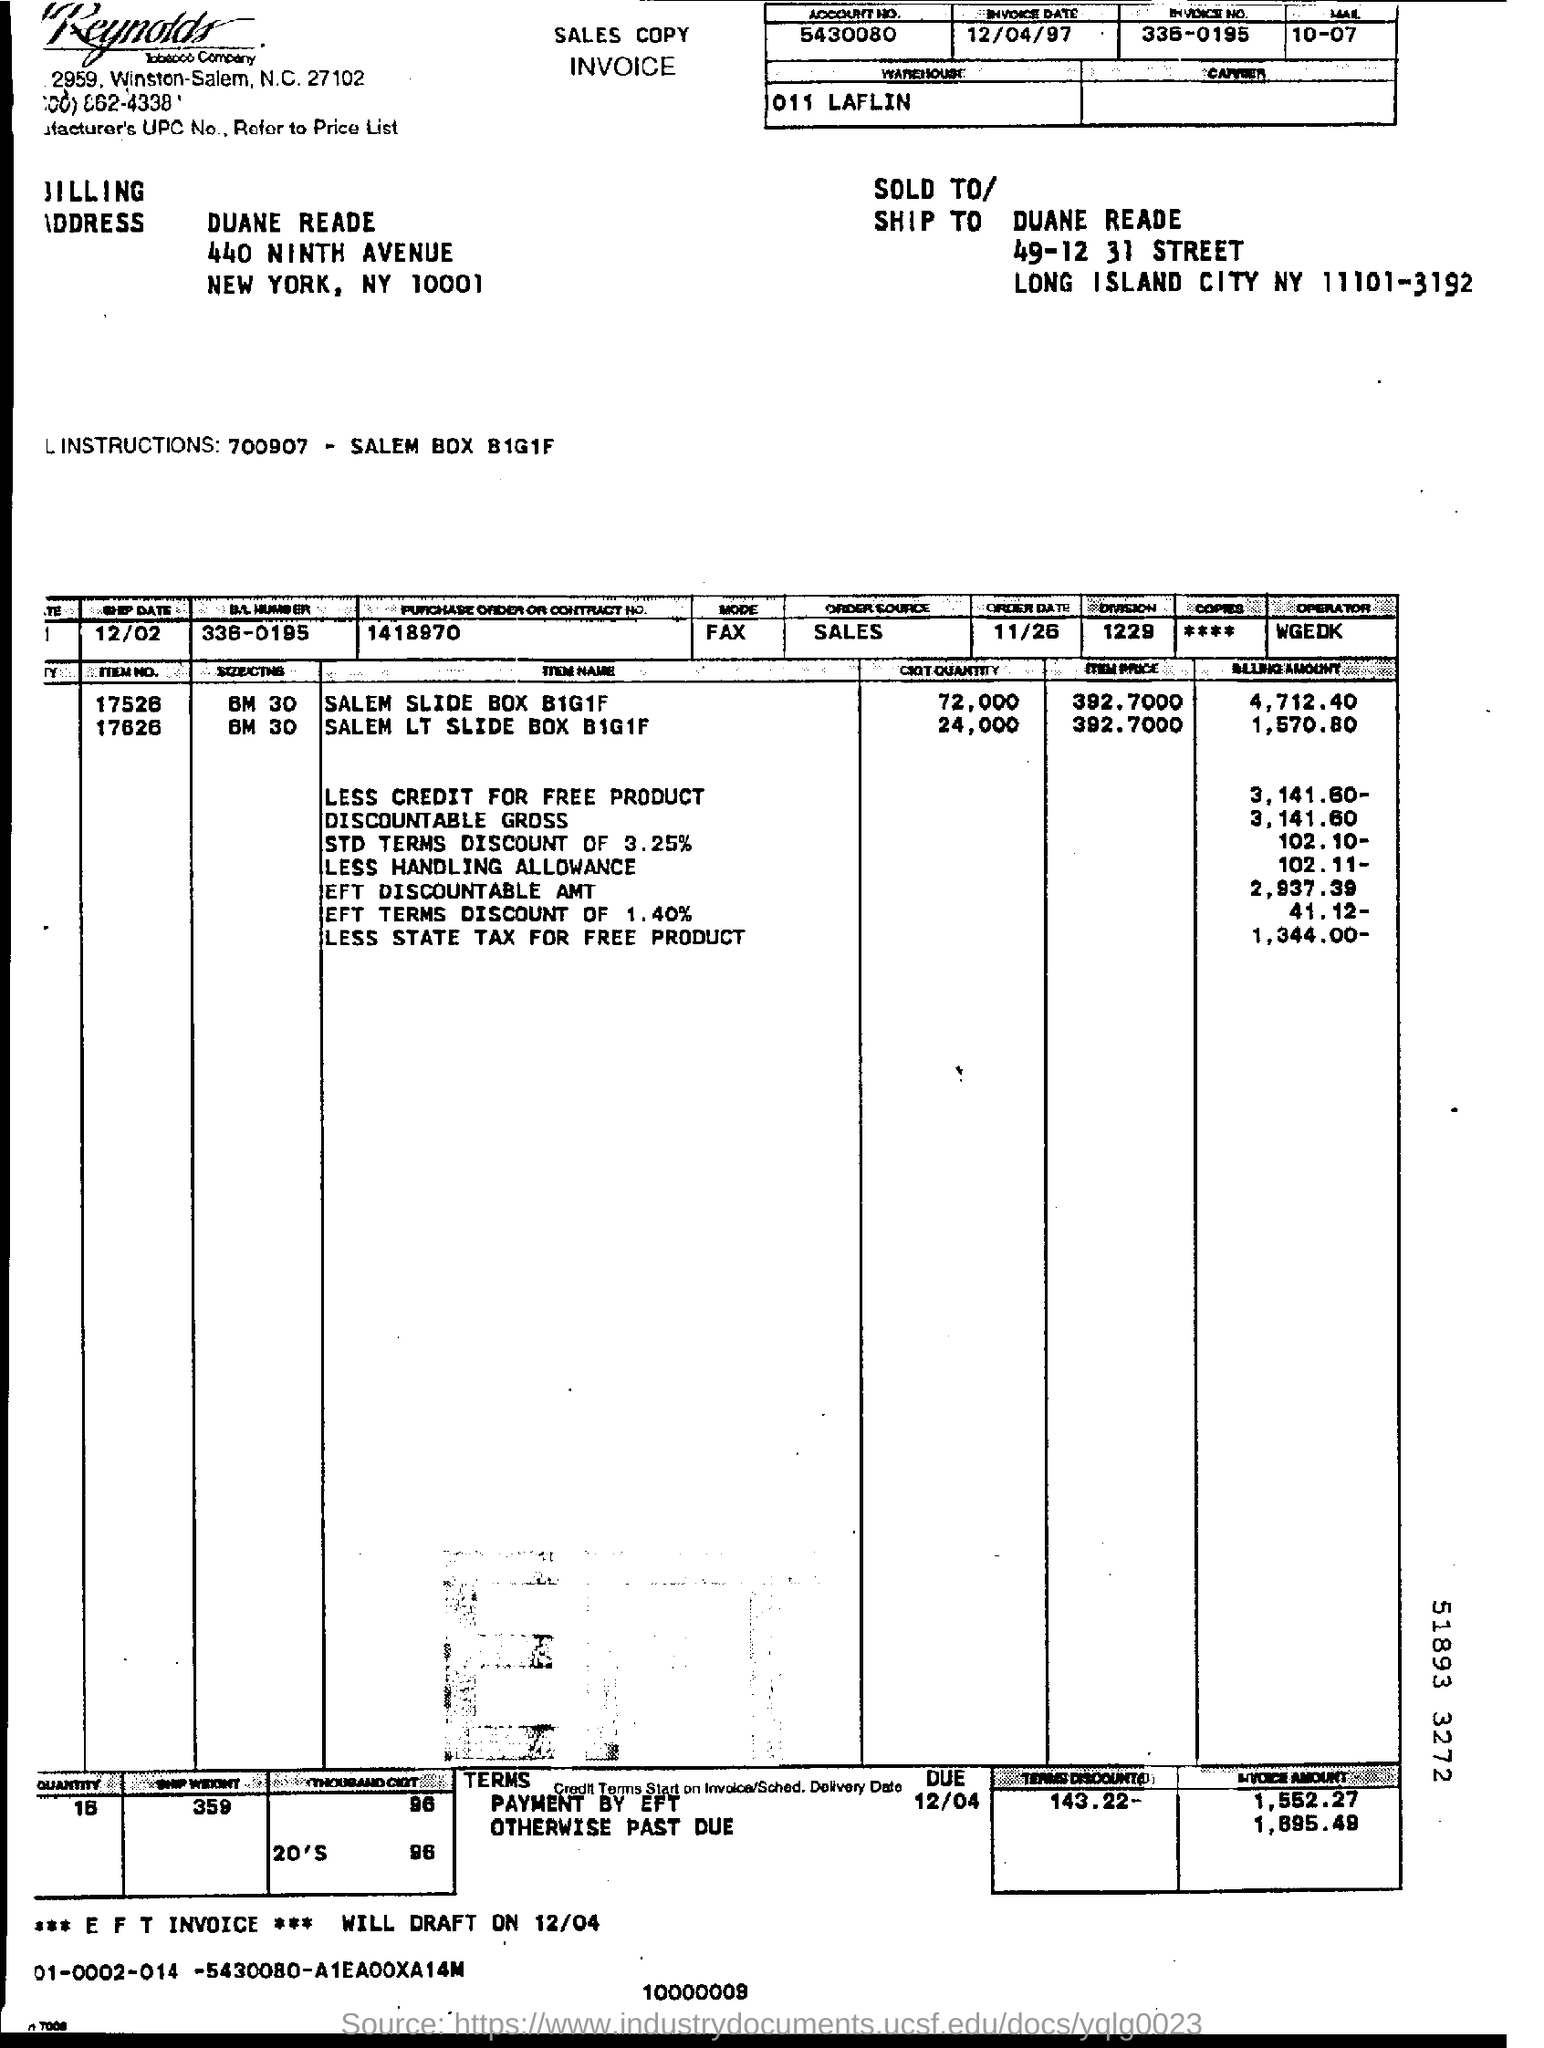What is the billing amount of SALEM SLIDE BOX B1G1F?
Your answer should be compact. 4,712.40. 